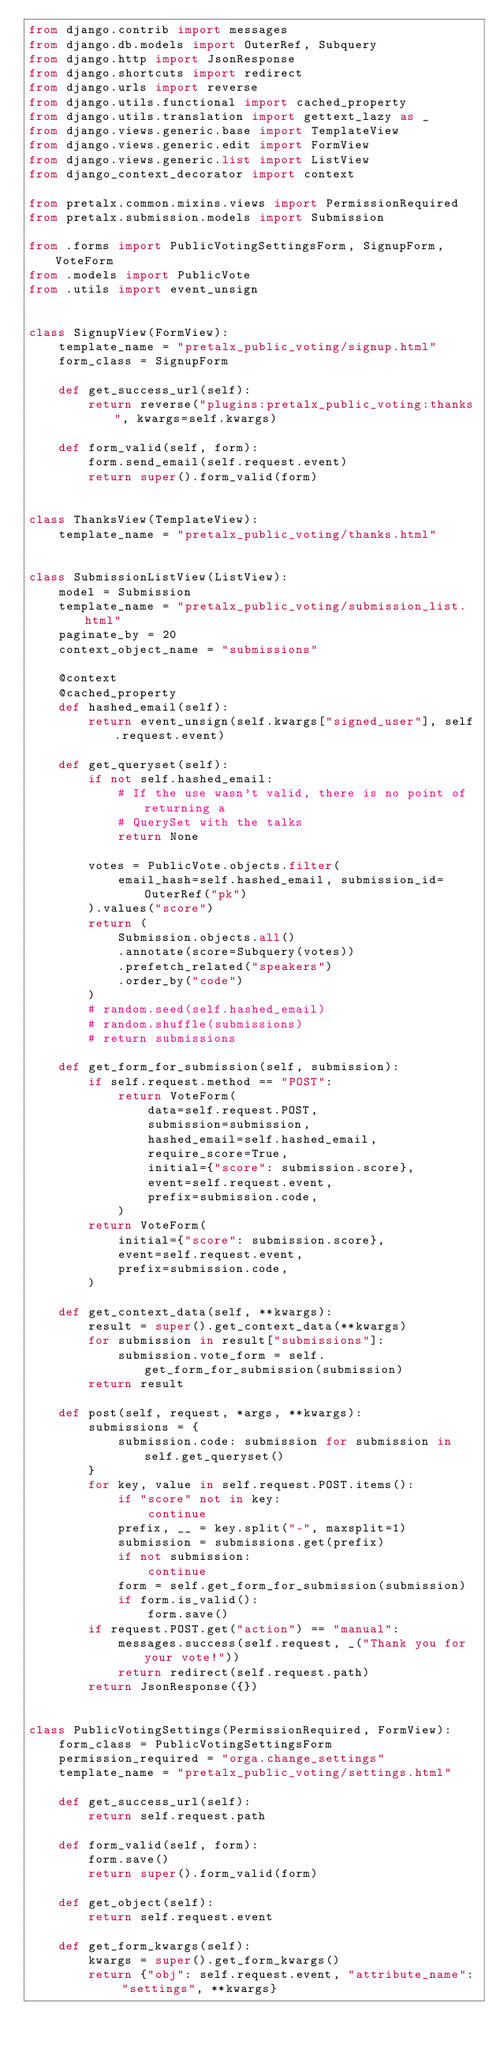<code> <loc_0><loc_0><loc_500><loc_500><_Python_>from django.contrib import messages
from django.db.models import OuterRef, Subquery
from django.http import JsonResponse
from django.shortcuts import redirect
from django.urls import reverse
from django.utils.functional import cached_property
from django.utils.translation import gettext_lazy as _
from django.views.generic.base import TemplateView
from django.views.generic.edit import FormView
from django.views.generic.list import ListView
from django_context_decorator import context

from pretalx.common.mixins.views import PermissionRequired
from pretalx.submission.models import Submission

from .forms import PublicVotingSettingsForm, SignupForm, VoteForm
from .models import PublicVote
from .utils import event_unsign


class SignupView(FormView):
    template_name = "pretalx_public_voting/signup.html"
    form_class = SignupForm

    def get_success_url(self):
        return reverse("plugins:pretalx_public_voting:thanks", kwargs=self.kwargs)

    def form_valid(self, form):
        form.send_email(self.request.event)
        return super().form_valid(form)


class ThanksView(TemplateView):
    template_name = "pretalx_public_voting/thanks.html"


class SubmissionListView(ListView):
    model = Submission
    template_name = "pretalx_public_voting/submission_list.html"
    paginate_by = 20
    context_object_name = "submissions"

    @context
    @cached_property
    def hashed_email(self):
        return event_unsign(self.kwargs["signed_user"], self.request.event)

    def get_queryset(self):
        if not self.hashed_email:
            # If the use wasn't valid, there is no point of returning a
            # QuerySet with the talks
            return None

        votes = PublicVote.objects.filter(
            email_hash=self.hashed_email, submission_id=OuterRef("pk")
        ).values("score")
        return (
            Submission.objects.all()
            .annotate(score=Subquery(votes))
            .prefetch_related("speakers")
            .order_by("code")
        )
        # random.seed(self.hashed_email)
        # random.shuffle(submissions)
        # return submissions

    def get_form_for_submission(self, submission):
        if self.request.method == "POST":
            return VoteForm(
                data=self.request.POST,
                submission=submission,
                hashed_email=self.hashed_email,
                require_score=True,
                initial={"score": submission.score},
                event=self.request.event,
                prefix=submission.code,
            )
        return VoteForm(
            initial={"score": submission.score},
            event=self.request.event,
            prefix=submission.code,
        )

    def get_context_data(self, **kwargs):
        result = super().get_context_data(**kwargs)
        for submission in result["submissions"]:
            submission.vote_form = self.get_form_for_submission(submission)
        return result

    def post(self, request, *args, **kwargs):
        submissions = {
            submission.code: submission for submission in self.get_queryset()
        }
        for key, value in self.request.POST.items():
            if "score" not in key:
                continue
            prefix, __ = key.split("-", maxsplit=1)
            submission = submissions.get(prefix)
            if not submission:
                continue
            form = self.get_form_for_submission(submission)
            if form.is_valid():
                form.save()
        if request.POST.get("action") == "manual":
            messages.success(self.request, _("Thank you for your vote!"))
            return redirect(self.request.path)
        return JsonResponse({})


class PublicVotingSettings(PermissionRequired, FormView):
    form_class = PublicVotingSettingsForm
    permission_required = "orga.change_settings"
    template_name = "pretalx_public_voting/settings.html"

    def get_success_url(self):
        return self.request.path

    def form_valid(self, form):
        form.save()
        return super().form_valid(form)

    def get_object(self):
        return self.request.event

    def get_form_kwargs(self):
        kwargs = super().get_form_kwargs()
        return {"obj": self.request.event, "attribute_name": "settings", **kwargs}
</code> 